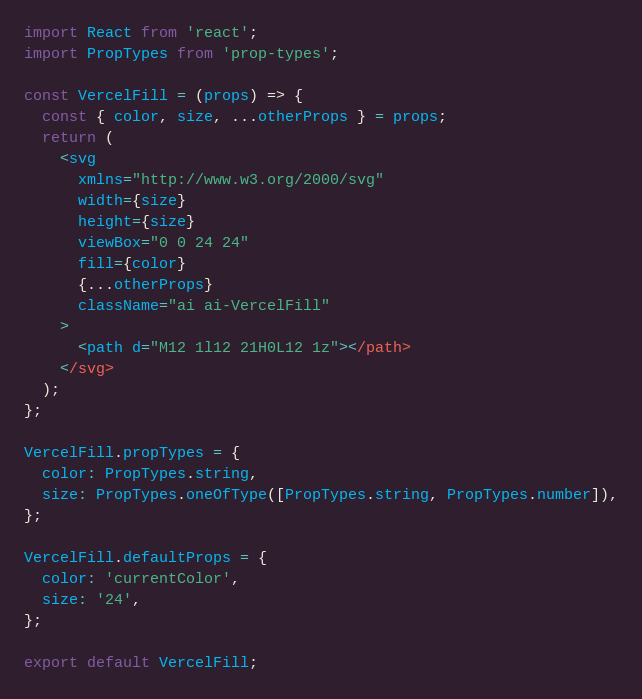<code> <loc_0><loc_0><loc_500><loc_500><_JavaScript_>import React from 'react';
import PropTypes from 'prop-types';

const VercelFill = (props) => {
  const { color, size, ...otherProps } = props;
  return (
    <svg
      xmlns="http://www.w3.org/2000/svg"
      width={size}
      height={size}
      viewBox="0 0 24 24"
      fill={color}
      {...otherProps}
      className="ai ai-VercelFill"
    >
      <path d="M12 1l12 21H0L12 1z"></path>
    </svg>
  );
};

VercelFill.propTypes = {
  color: PropTypes.string,
  size: PropTypes.oneOfType([PropTypes.string, PropTypes.number]),
};

VercelFill.defaultProps = {
  color: 'currentColor',
  size: '24',
};

export default VercelFill;
</code> 